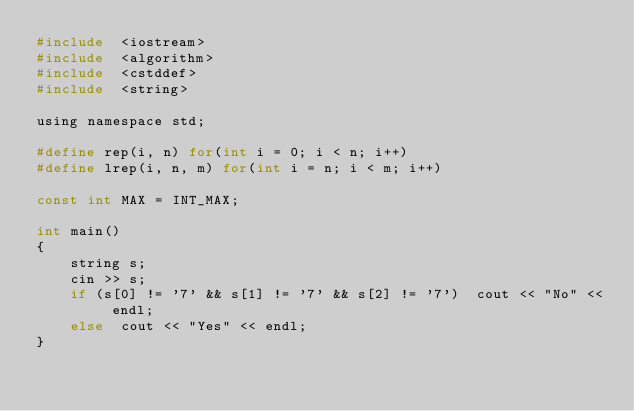Convert code to text. <code><loc_0><loc_0><loc_500><loc_500><_C_>#include  <iostream>
#include  <algorithm>
#include  <cstddef>
#include  <string>

using namespace std;

#define rep(i, n) for(int i = 0; i < n; i++)
#define lrep(i, n, m) for(int i = n; i < m; i++)

const int MAX = INT_MAX;

int main()
{	
	string s;
	cin >> s;
	if (s[0] != '7' && s[1] != '7' && s[2] != '7')  cout << "No" << endl;
	else  cout << "Yes" << endl;
}</code> 